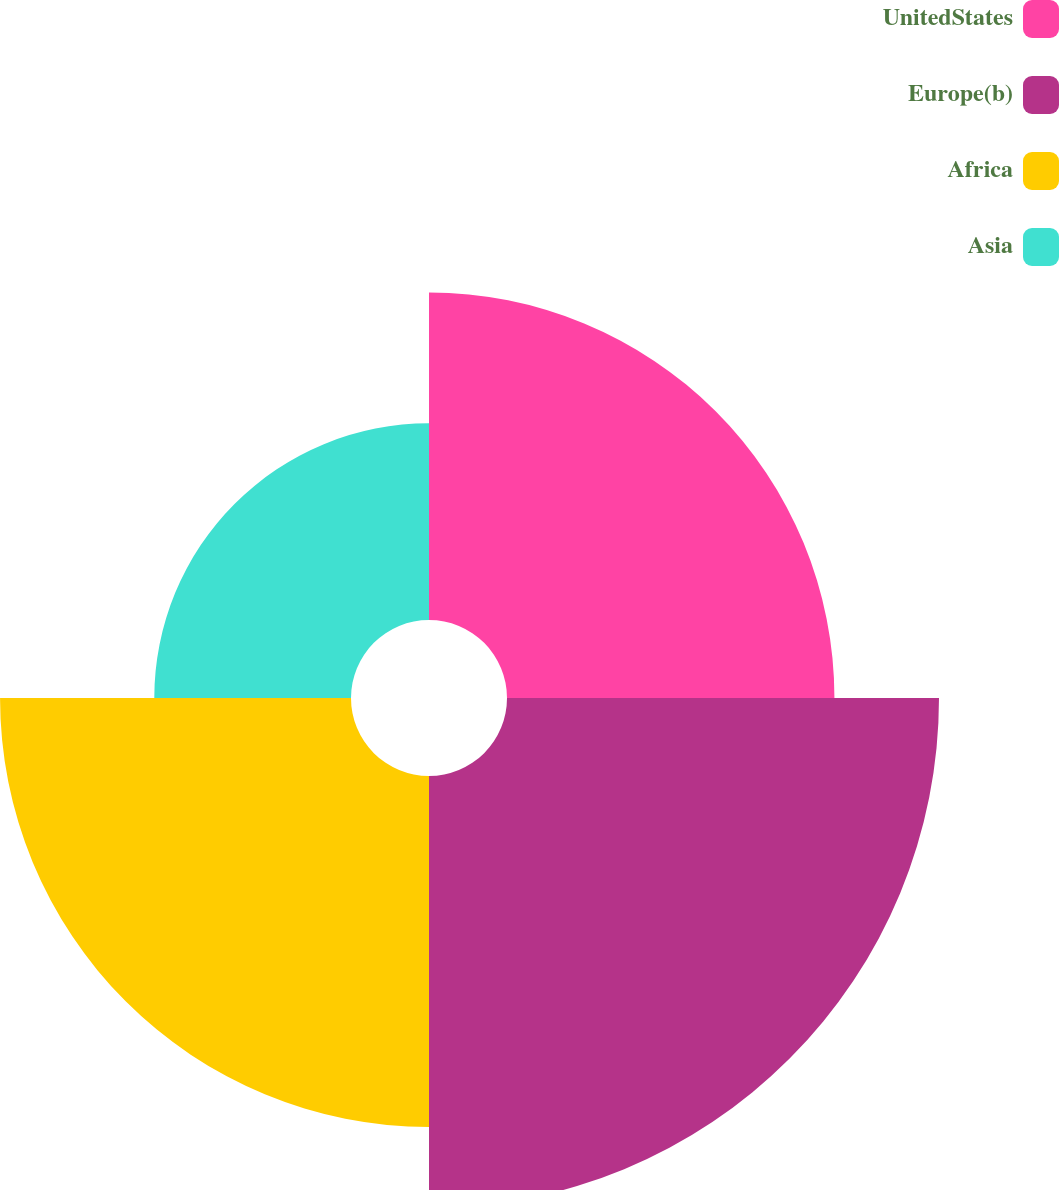<chart> <loc_0><loc_0><loc_500><loc_500><pie_chart><fcel>UnitedStates<fcel>Europe(b)<fcel>Africa<fcel>Asia<nl><fcel>25.05%<fcel>33.05%<fcel>26.85%<fcel>15.05%<nl></chart> 